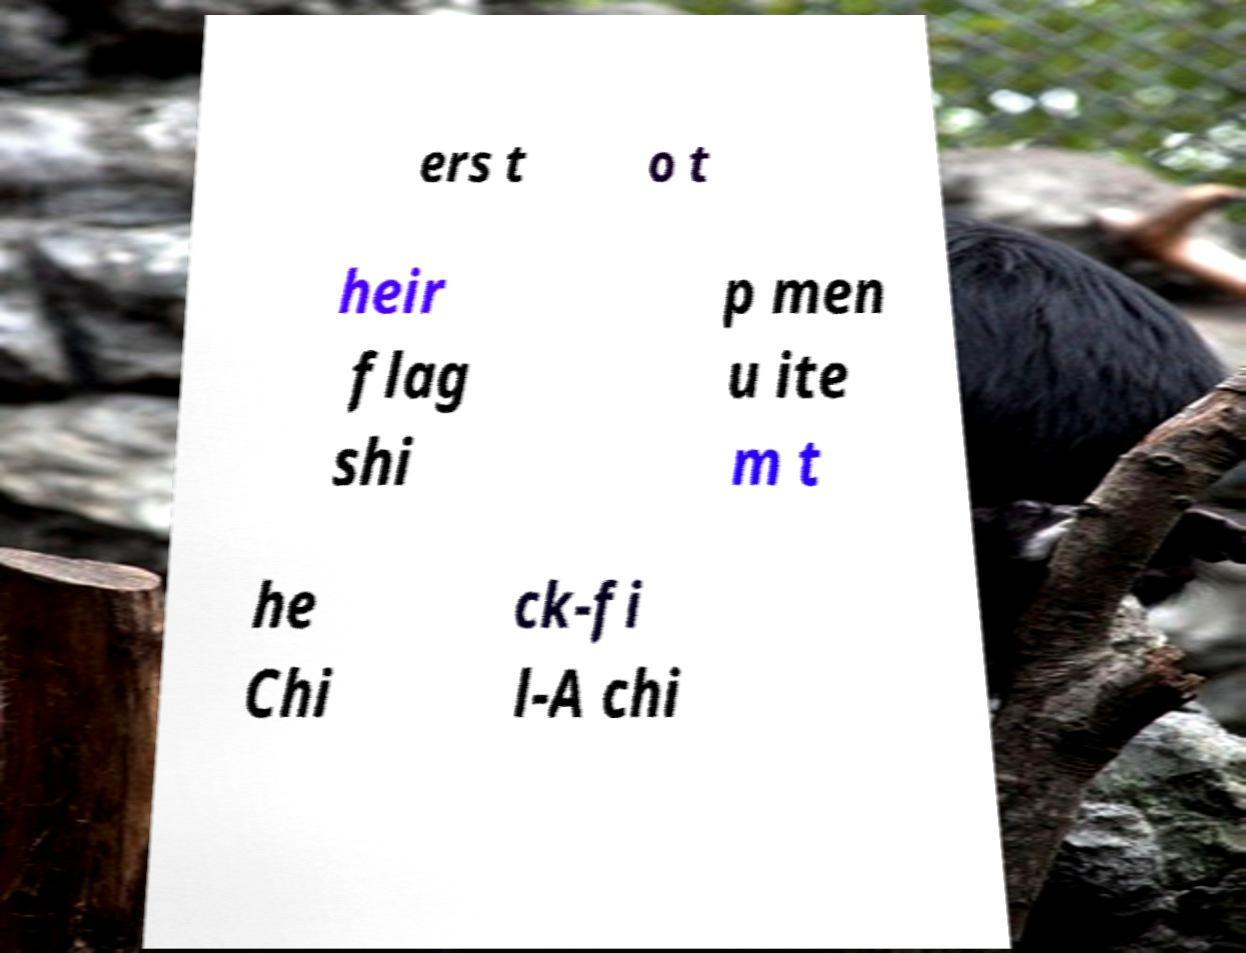Please identify and transcribe the text found in this image. ers t o t heir flag shi p men u ite m t he Chi ck-fi l-A chi 